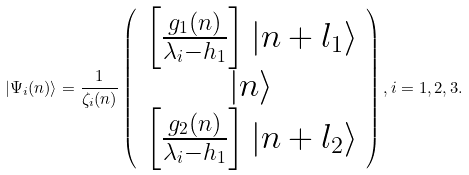Convert formula to latex. <formula><loc_0><loc_0><loc_500><loc_500>| \Psi _ { i } ( n ) \rangle = \frac { 1 } { \zeta _ { i } ( n ) } \left ( \begin{array} { c } \left [ \frac { g _ { 1 } ( n ) } { \lambda _ { i } - h _ { 1 } } \right ] | n + l _ { 1 } \rangle \\ | n \rangle \\ \left [ \frac { g _ { 2 } ( n ) } { \lambda _ { i } - h _ { 1 } } \right ] | n + l _ { 2 } \rangle \end{array} \right ) , i = 1 , 2 , 3 .</formula> 